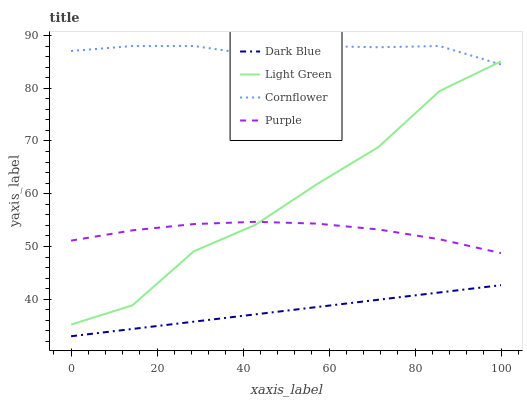Does Light Green have the minimum area under the curve?
Answer yes or no. No. Does Light Green have the maximum area under the curve?
Answer yes or no. No. Is Light Green the smoothest?
Answer yes or no. No. Is Dark Blue the roughest?
Answer yes or no. No. Does Light Green have the lowest value?
Answer yes or no. No. Does Light Green have the highest value?
Answer yes or no. No. Is Dark Blue less than Cornflower?
Answer yes or no. Yes. Is Purple greater than Dark Blue?
Answer yes or no. Yes. Does Dark Blue intersect Cornflower?
Answer yes or no. No. 